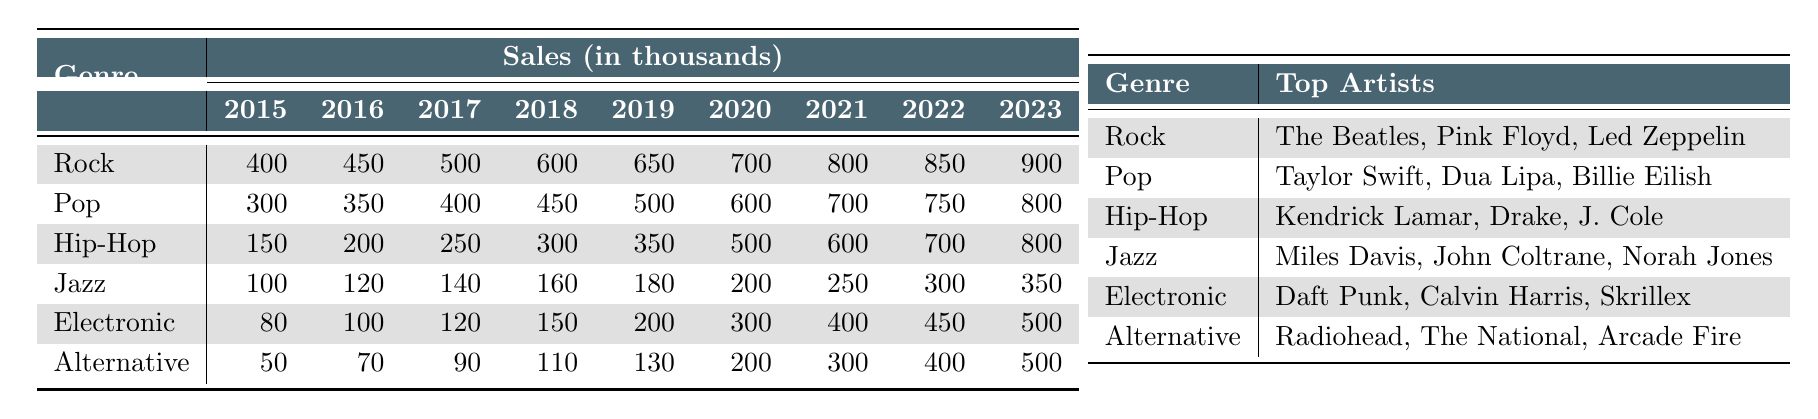What genre had the highest sales in 2023? In 2023, Rock had the highest sales with 900,000 units sold compared to other genres.
Answer: Rock What were the sales of Jazz in 2019? The sales of Jazz in 2019 were 180,000 units, as indicated in the sales column for that year.
Answer: 180,000 Which genre experienced the largest growth in sales from 2015 to 2023? To find the growth, calculate the difference in sales between 2015 and 2023 for each genre. Rock had a growth of 500,000 units (900,000 - 400,000), which is more than any other genre, making it the largest growth.
Answer: Rock What is the average sales of Pop records from 2015 to 2023? The sales values for Pop from 2015 to 2023 are 300,000, 350,000, 400,000, 450,000, 500,000, 600,000, 700,000, 750,000, and 800,000. Adding these up gives a total of 3,550,000, which when divided by 9 (the number of years) equals approximately 394,444.
Answer: 394,444 Is it true that Electronic genre had more sales in 2022 compared to Jazz? In 2022, Electronic sales were 450,000 and Jazz sales were 300,000. Since 450,000 is greater than 300,000, the statement is true.
Answer: Yes What were the top three artists in the Hip-Hop genre? The table lists Kendrick Lamar, Drake, and J. Cole as the top three artists for the Hip-Hop genre.
Answer: Kendrick Lamar, Drake, J. Cole What was the percentage increase in sales for Alternative from 2015 to 2021? Alternative sales increased from 50,000 in 2015 to 300,000 in 2021. The increase is 250,000. To find the percentage increase: (250,000 / 50,000) * 100 = 500%.
Answer: 500% Which genre had the smallest sales in 2015? Examining the sales data for 2015, Alternative had the smallest sales at 50,000.
Answer: Alternative What is the total sales for all genres combined in 2020? Adding the sales for all genres in 2020 gives: Rock (700,000) + Pop (600,000) + Hip-Hop (500,000) + Jazz (200,000) + Electronic (300,000) + Alternative (200,000) = 2,600,000 units.
Answer: 2,600,000 Which genre had consistent growth in sales every year from 2015 to 2023? By viewing the sales trends, it’s clear that Rock, Pop, and Hip-Hop showed consistent growth year over year, with no decreases.
Answer: Rock, Pop, Hip-Hop 